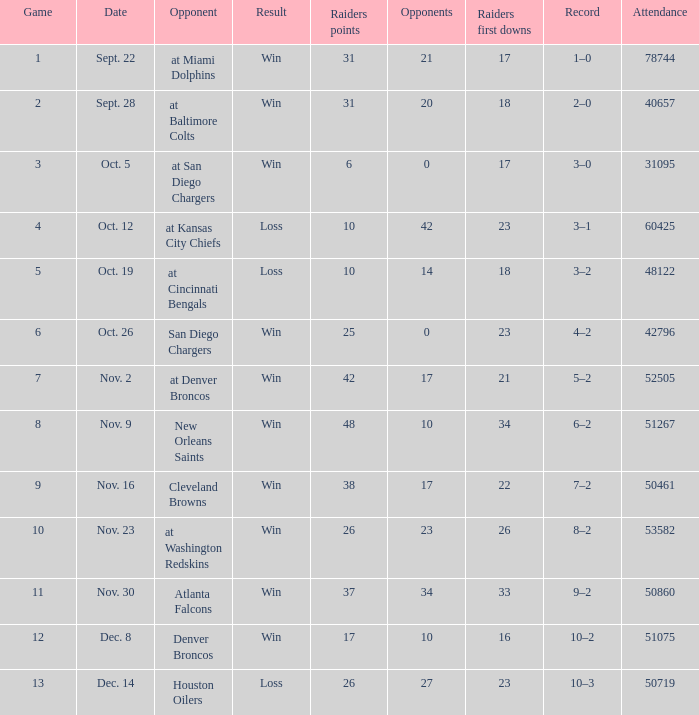What's the record in the game played against 42? 3–1. 